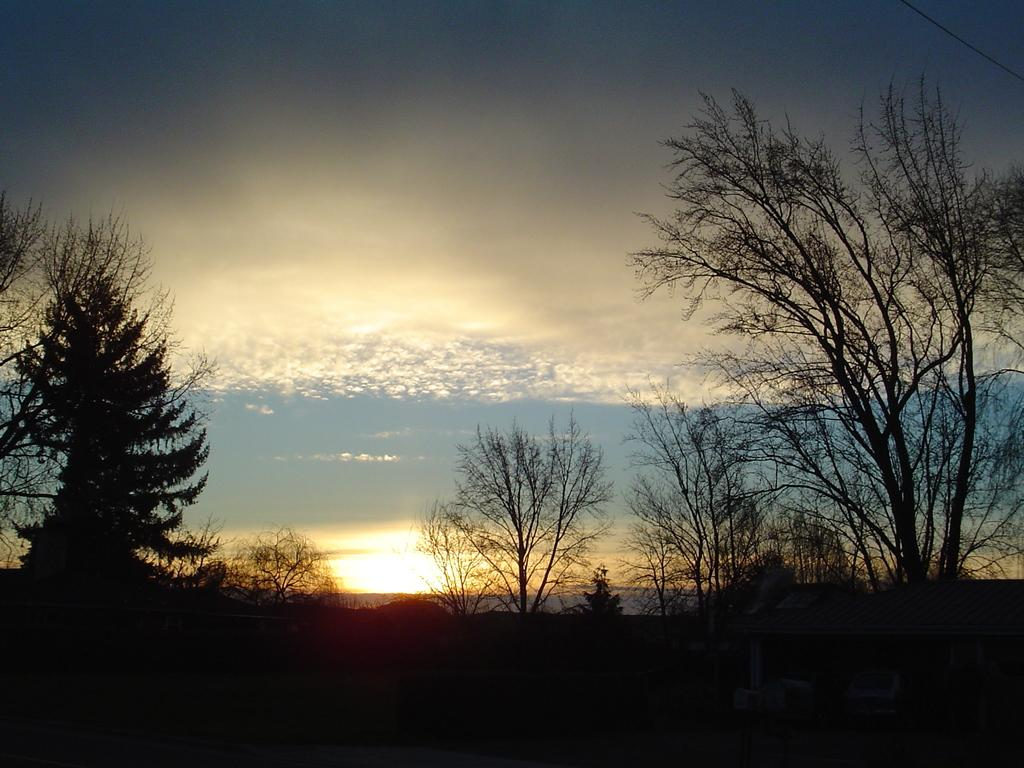What type of vegetation can be seen in the image? There are trees in the image. How would you describe the sky in the image? The sky is blue and cloudy in the image. What book is the tree reading in the image? There is no book or tree reading in the image; it features trees and a blue, cloudy sky. What type of straw is visible in the image? There is no straw present in the image. 